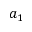<formula> <loc_0><loc_0><loc_500><loc_500>a _ { 1 }</formula> 